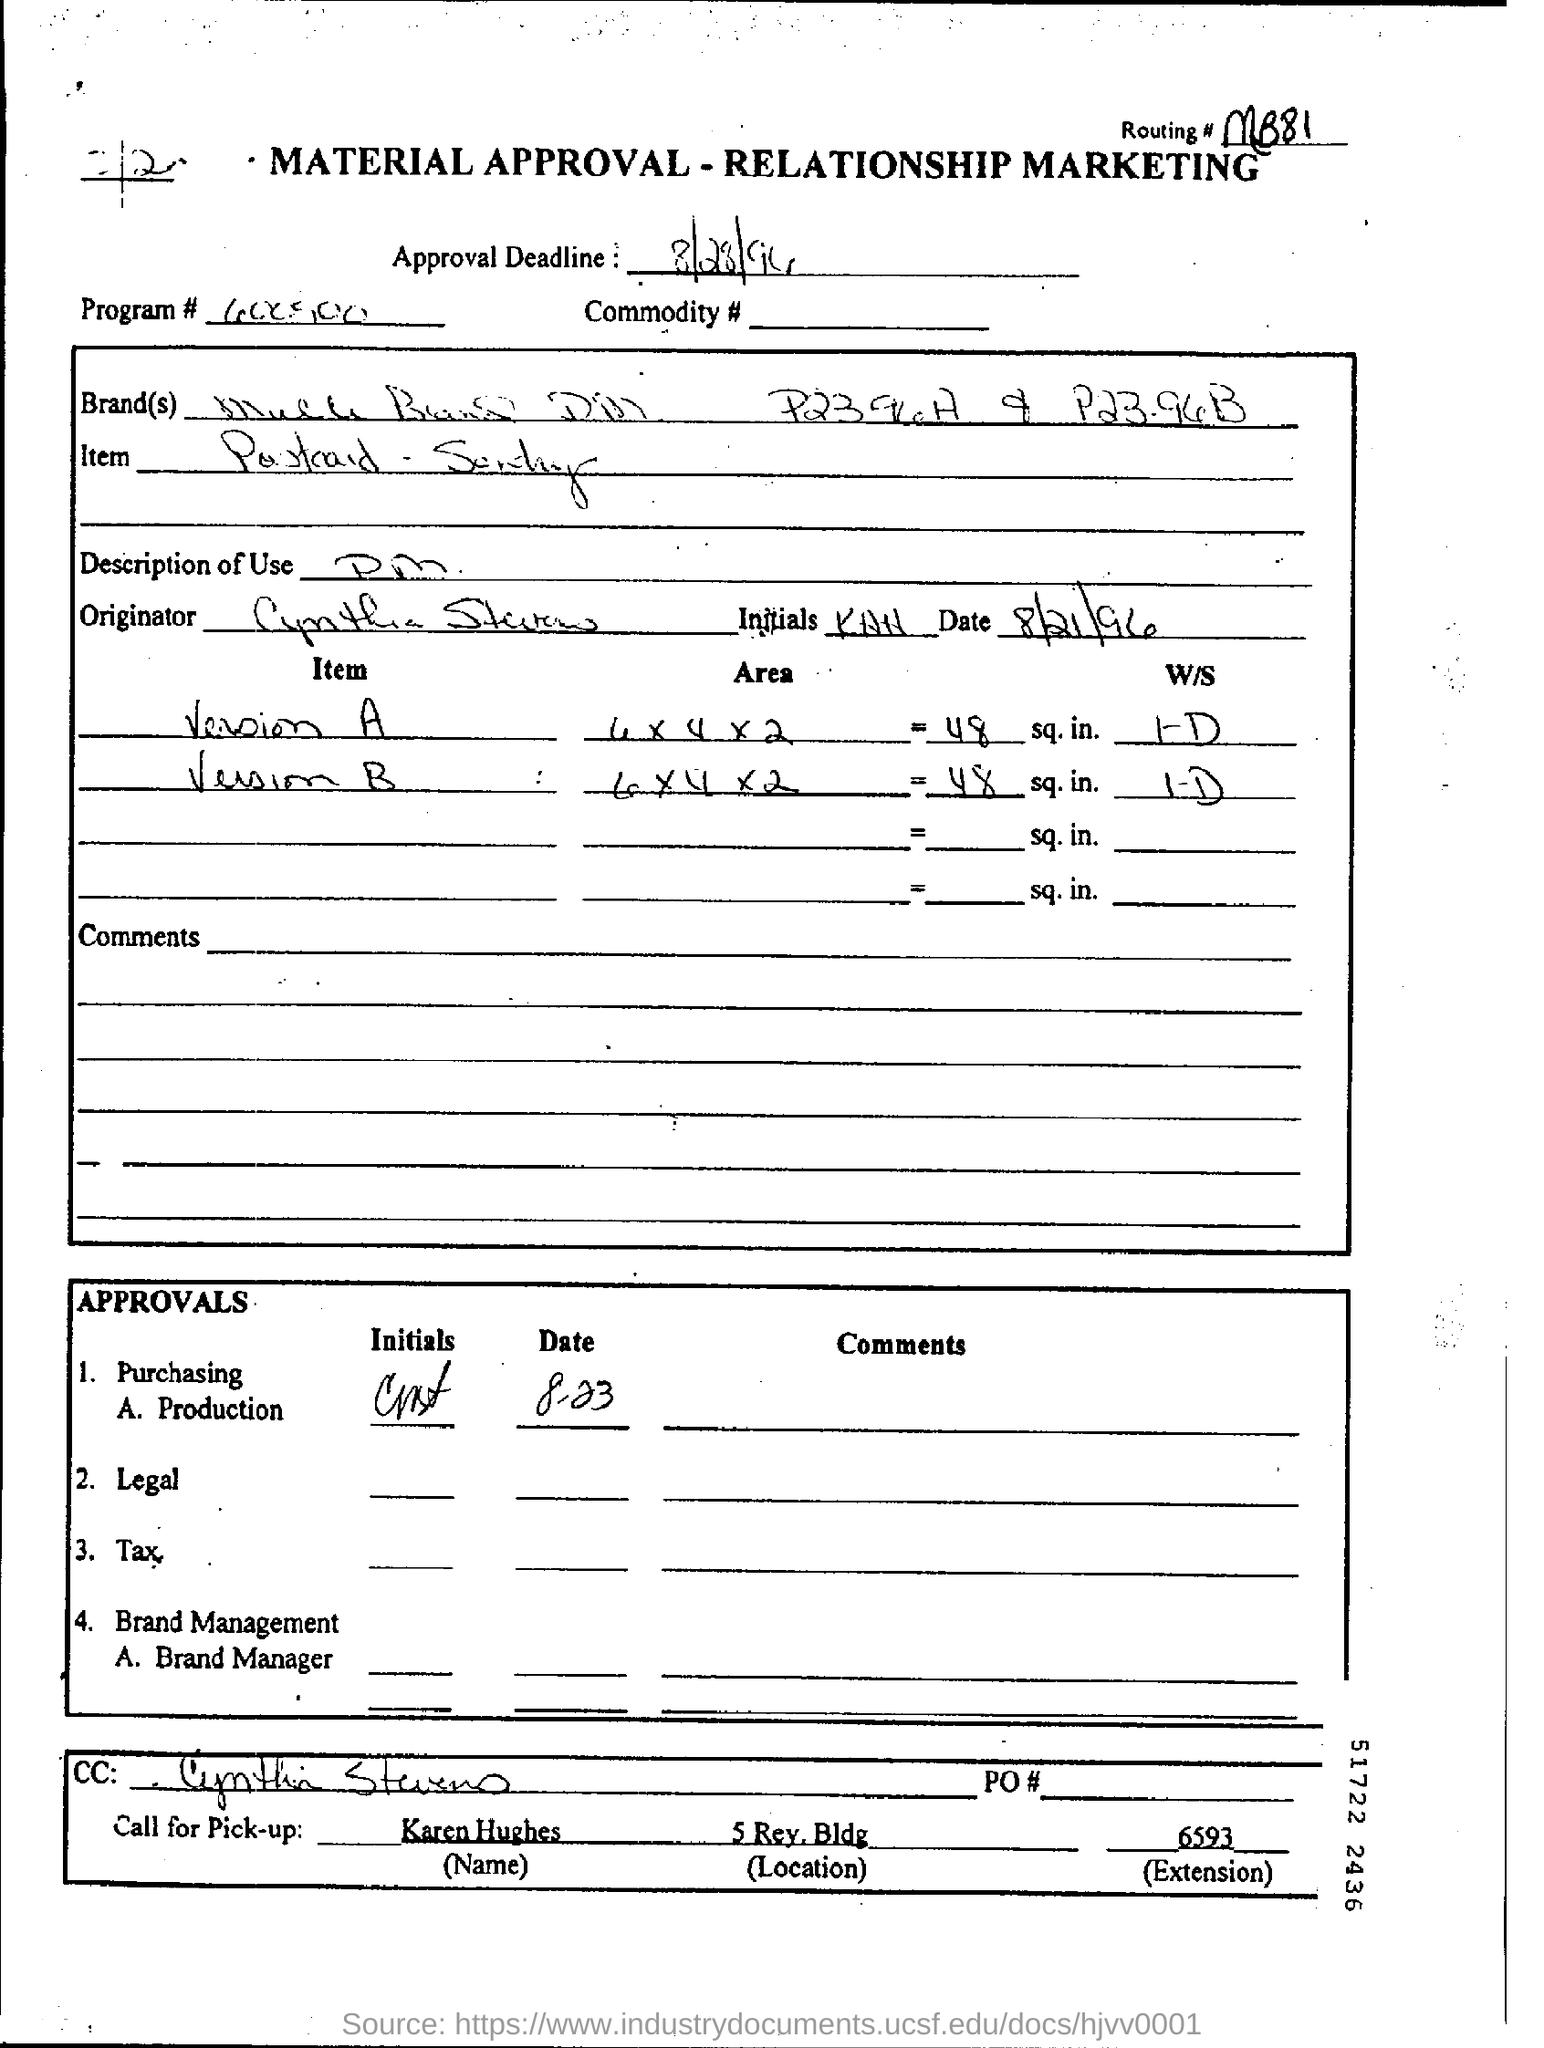What is the routing number given?
Provide a short and direct response. MB81. What is the approval deadline?
Ensure brevity in your answer.  8/28/94. When is the approval deadline mentioned in the form?
Your response must be concise. 8/28/94. Who is marked in the cc?
Ensure brevity in your answer.  Cynthia Stevens. Who should be called for pick-up?
Provide a short and direct response. Karen Hughes. 